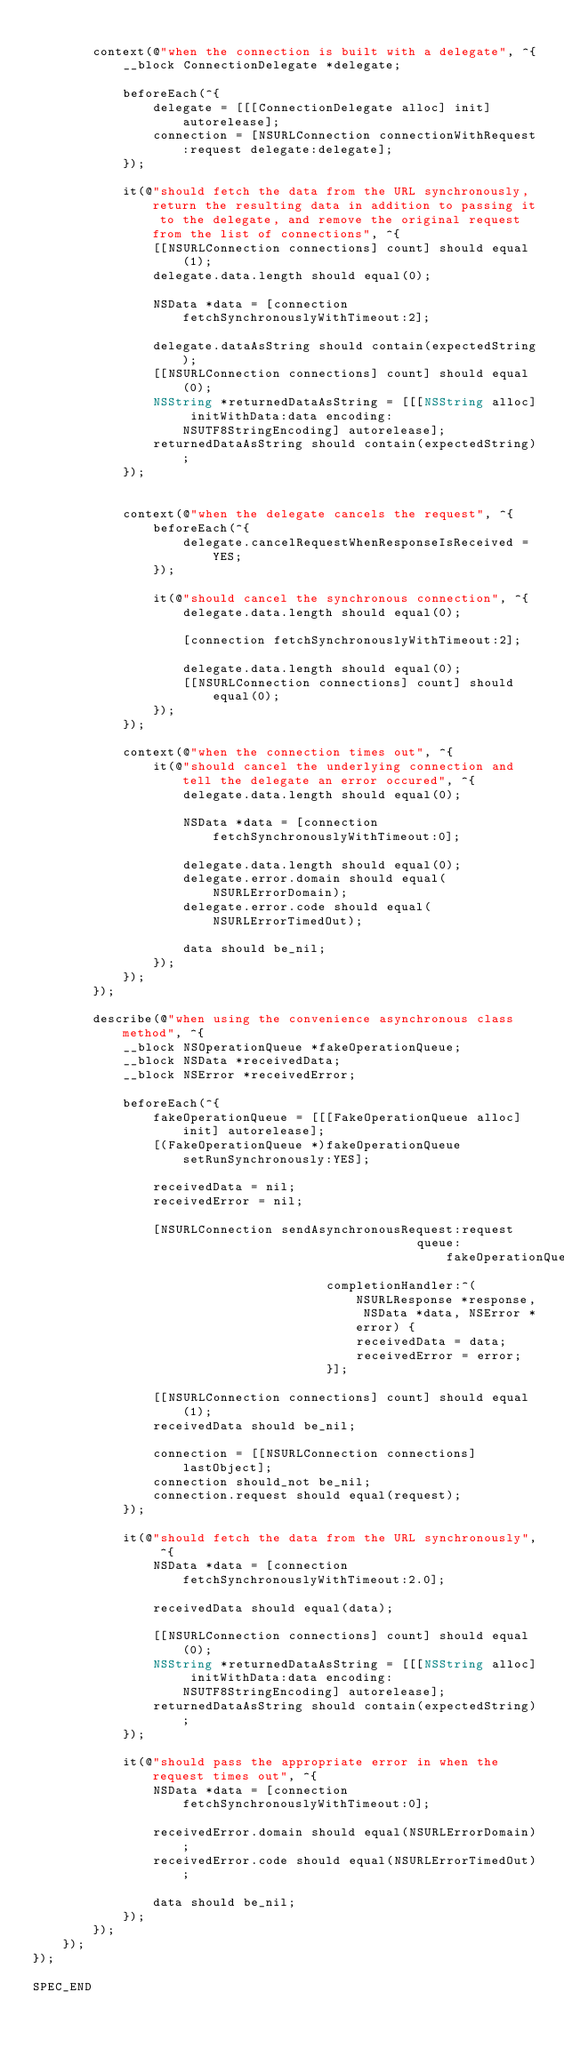Convert code to text. <code><loc_0><loc_0><loc_500><loc_500><_ObjectiveC_>
        context(@"when the connection is built with a delegate", ^{
            __block ConnectionDelegate *delegate;

            beforeEach(^{
                delegate = [[[ConnectionDelegate alloc] init] autorelease];
                connection = [NSURLConnection connectionWithRequest:request delegate:delegate];
            });

            it(@"should fetch the data from the URL synchronously, return the resulting data in addition to passing it to the delegate, and remove the original request from the list of connections", ^{
                [[NSURLConnection connections] count] should equal(1);
                delegate.data.length should equal(0);

                NSData *data = [connection fetchSynchronouslyWithTimeout:2];

                delegate.dataAsString should contain(expectedString);
                [[NSURLConnection connections] count] should equal(0);
                NSString *returnedDataAsString = [[[NSString alloc] initWithData:data encoding:NSUTF8StringEncoding] autorelease];
                returnedDataAsString should contain(expectedString);
            });


            context(@"when the delegate cancels the request", ^{
                beforeEach(^{
                    delegate.cancelRequestWhenResponseIsReceived = YES;
                });

                it(@"should cancel the synchronous connection", ^{
                    delegate.data.length should equal(0);

                    [connection fetchSynchronouslyWithTimeout:2];

                    delegate.data.length should equal(0);
                    [[NSURLConnection connections] count] should equal(0);
                });
            });

            context(@"when the connection times out", ^{
                it(@"should cancel the underlying connection and tell the delegate an error occured", ^{
                    delegate.data.length should equal(0);

                    NSData *data = [connection fetchSynchronouslyWithTimeout:0];

                    delegate.data.length should equal(0);
                    delegate.error.domain should equal(NSURLErrorDomain);
                    delegate.error.code should equal(NSURLErrorTimedOut);

                    data should be_nil;
                });
            });
        });

        describe(@"when using the convenience asynchronous class method", ^{
            __block NSOperationQueue *fakeOperationQueue;
            __block NSData *receivedData;
            __block NSError *receivedError;

            beforeEach(^{
                fakeOperationQueue = [[[FakeOperationQueue alloc] init] autorelease];
                [(FakeOperationQueue *)fakeOperationQueue setRunSynchronously:YES];

                receivedData = nil;
                receivedError = nil;

                [NSURLConnection sendAsynchronousRequest:request
                                                   queue:fakeOperationQueue
                                       completionHandler:^(NSURLResponse *response, NSData *data, NSError *error) {
                                           receivedData = data;
                                           receivedError = error;
                                       }];

                [[NSURLConnection connections] count] should equal(1);
                receivedData should be_nil;

                connection = [[NSURLConnection connections] lastObject];
                connection should_not be_nil;
                connection.request should equal(request);
            });

            it(@"should fetch the data from the URL synchronously", ^{
                NSData *data = [connection fetchSynchronouslyWithTimeout:2.0];

                receivedData should equal(data);

                [[NSURLConnection connections] count] should equal(0);
                NSString *returnedDataAsString = [[[NSString alloc] initWithData:data encoding:NSUTF8StringEncoding] autorelease];
                returnedDataAsString should contain(expectedString);
            });

            it(@"should pass the appropriate error in when the request times out", ^{
                NSData *data = [connection fetchSynchronouslyWithTimeout:0];

                receivedError.domain should equal(NSURLErrorDomain);
                receivedError.code should equal(NSURLErrorTimedOut);

                data should be_nil;
            });
        });
    });
});

SPEC_END
</code> 